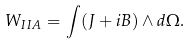<formula> <loc_0><loc_0><loc_500><loc_500>W _ { I I A } = \int ( J + i B ) \wedge d \Omega .</formula> 